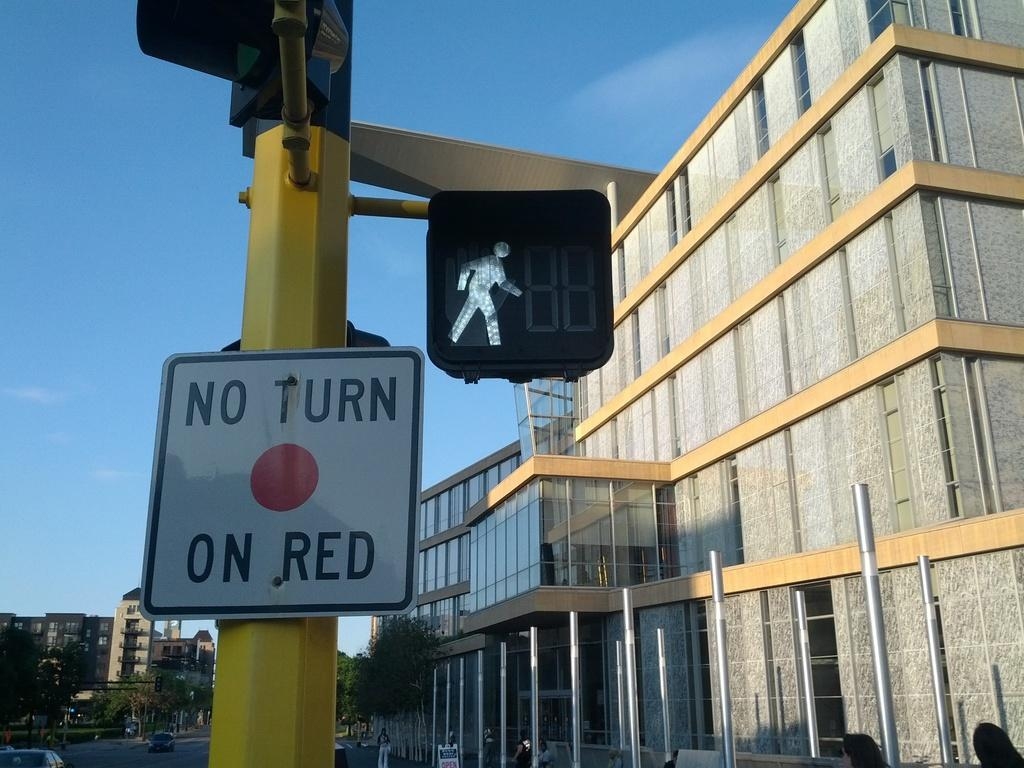<image>
Write a terse but informative summary of the picture. A traffic sign states no turn on red with a red circle. 